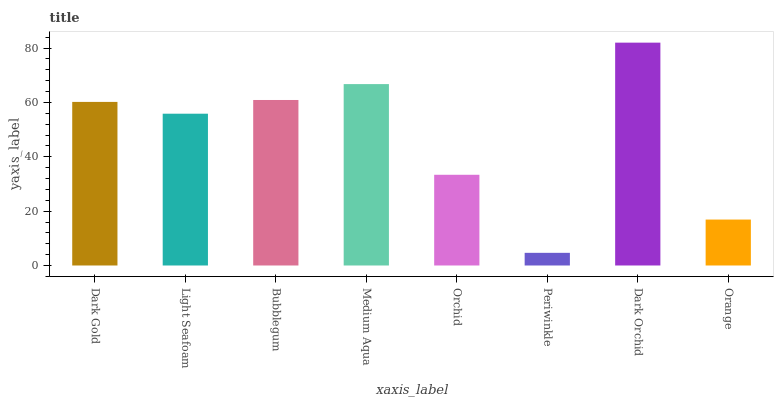Is Periwinkle the minimum?
Answer yes or no. Yes. Is Dark Orchid the maximum?
Answer yes or no. Yes. Is Light Seafoam the minimum?
Answer yes or no. No. Is Light Seafoam the maximum?
Answer yes or no. No. Is Dark Gold greater than Light Seafoam?
Answer yes or no. Yes. Is Light Seafoam less than Dark Gold?
Answer yes or no. Yes. Is Light Seafoam greater than Dark Gold?
Answer yes or no. No. Is Dark Gold less than Light Seafoam?
Answer yes or no. No. Is Dark Gold the high median?
Answer yes or no. Yes. Is Light Seafoam the low median?
Answer yes or no. Yes. Is Bubblegum the high median?
Answer yes or no. No. Is Medium Aqua the low median?
Answer yes or no. No. 